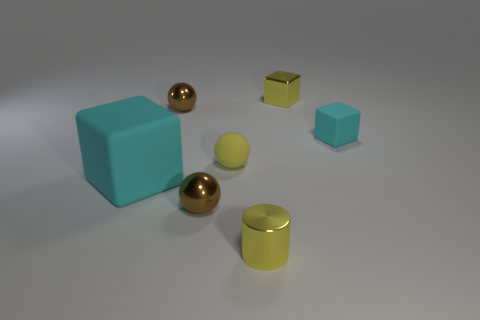Add 2 tiny red metallic cubes. How many objects exist? 9 Subtract all blocks. How many objects are left? 4 Subtract 0 brown blocks. How many objects are left? 7 Subtract all large cyan things. Subtract all big matte things. How many objects are left? 5 Add 6 metal spheres. How many metal spheres are left? 8 Add 2 tiny matte spheres. How many tiny matte spheres exist? 3 